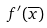<formula> <loc_0><loc_0><loc_500><loc_500>f ^ { \prime } ( \overline { x } )</formula> 